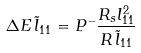<formula> <loc_0><loc_0><loc_500><loc_500>\Delta E \, \tilde { l } _ { 1 1 } = P ^ { - } \frac { R _ { s } { l } _ { 1 1 } ^ { 2 } } { R \, \tilde { l } _ { 1 1 } }</formula> 